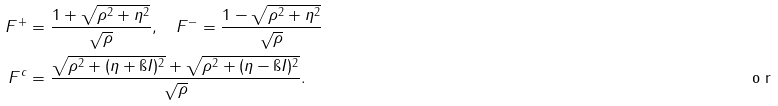Convert formula to latex. <formula><loc_0><loc_0><loc_500><loc_500>F ^ { + } & = \frac { 1 + \sqrt { \rho ^ { 2 } + \eta ^ { 2 } } } { \sqrt { \rho } } , \quad F ^ { - } = \frac { 1 - \sqrt { \rho ^ { 2 } + \eta ^ { 2 } } } { \sqrt { \rho } } \\ \tag* { o r } F ^ { c } & = \frac { \sqrt { \rho ^ { 2 } + ( \eta + \i I ) ^ { 2 } } + \sqrt { \rho ^ { 2 } + ( \eta - \i I ) ^ { 2 } } } { \sqrt { \rho } } .</formula> 